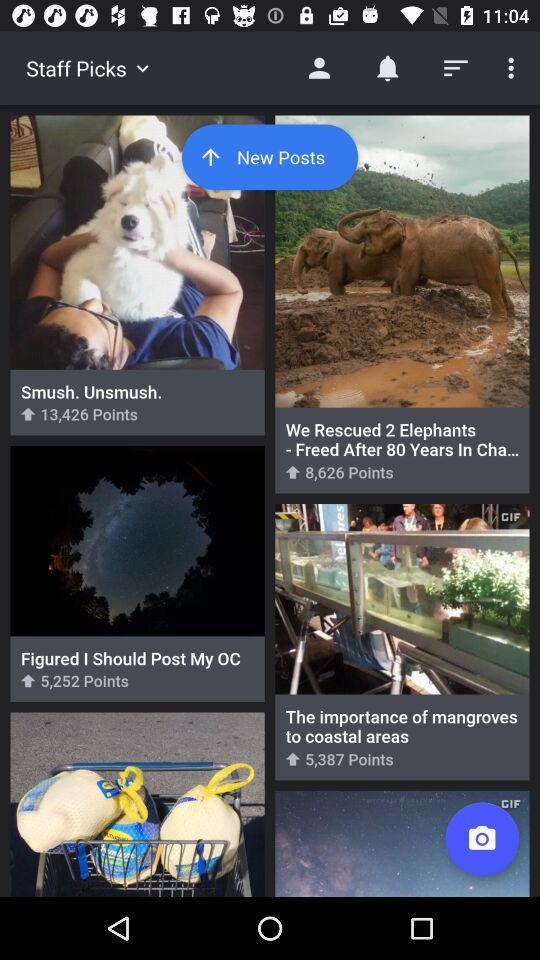How many points are there of "Smush. Unsmush."? There are 13,426 points of "Smush. Unsmush.". 